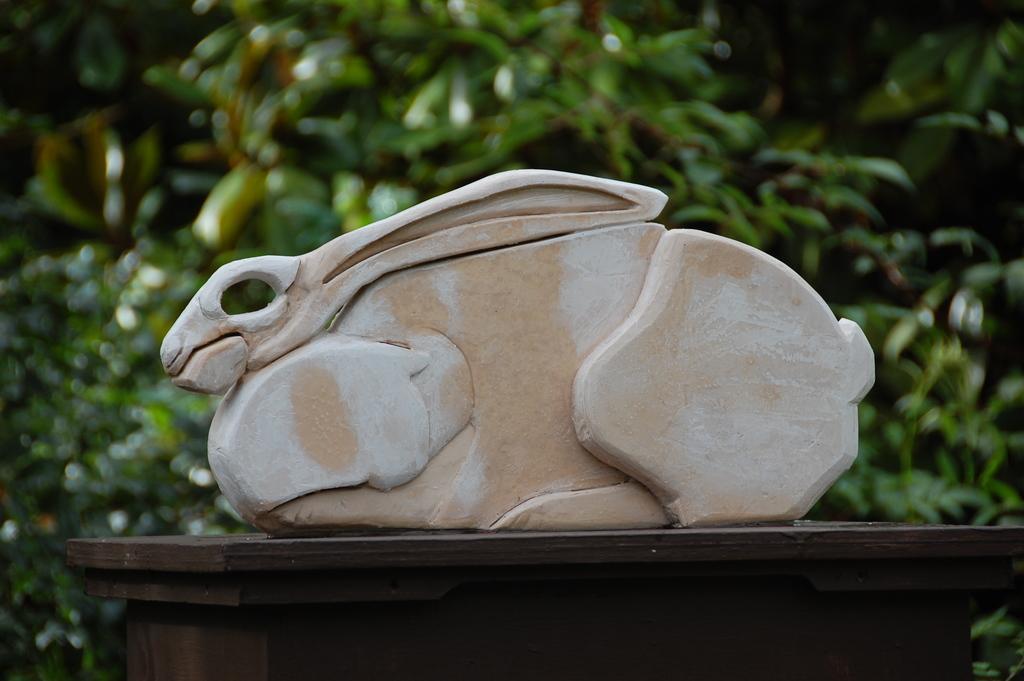Describe this image in one or two sentences. This is a zoomed in picture. In the center there is a sculpture of a rabbit placed on the top of the table. In the background we can see the plants. 